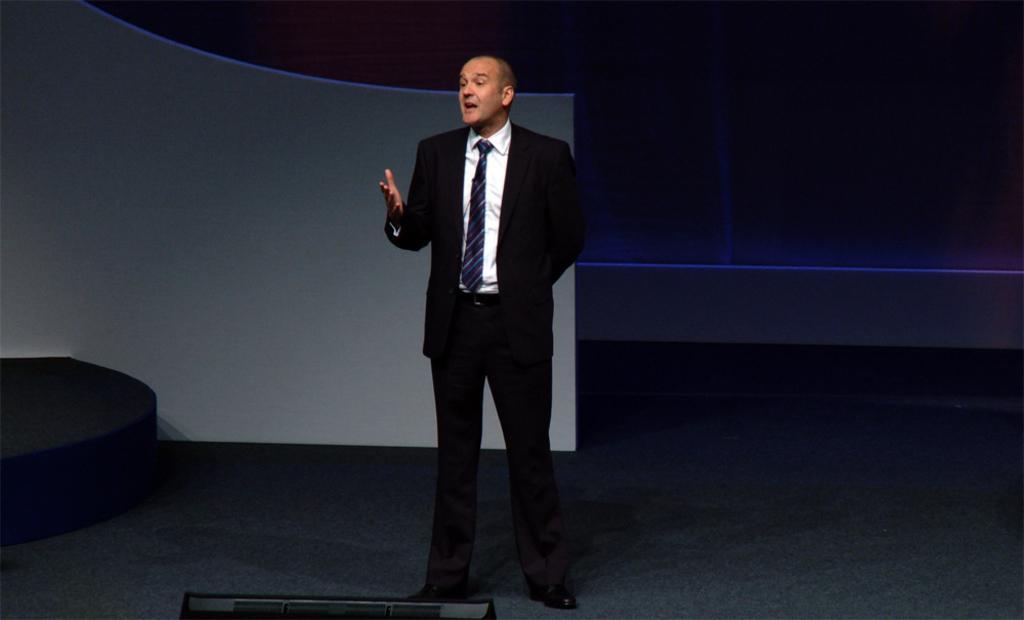Could you give a brief overview of what you see in this image? In the image I can see a person standing and wearing a blazer 